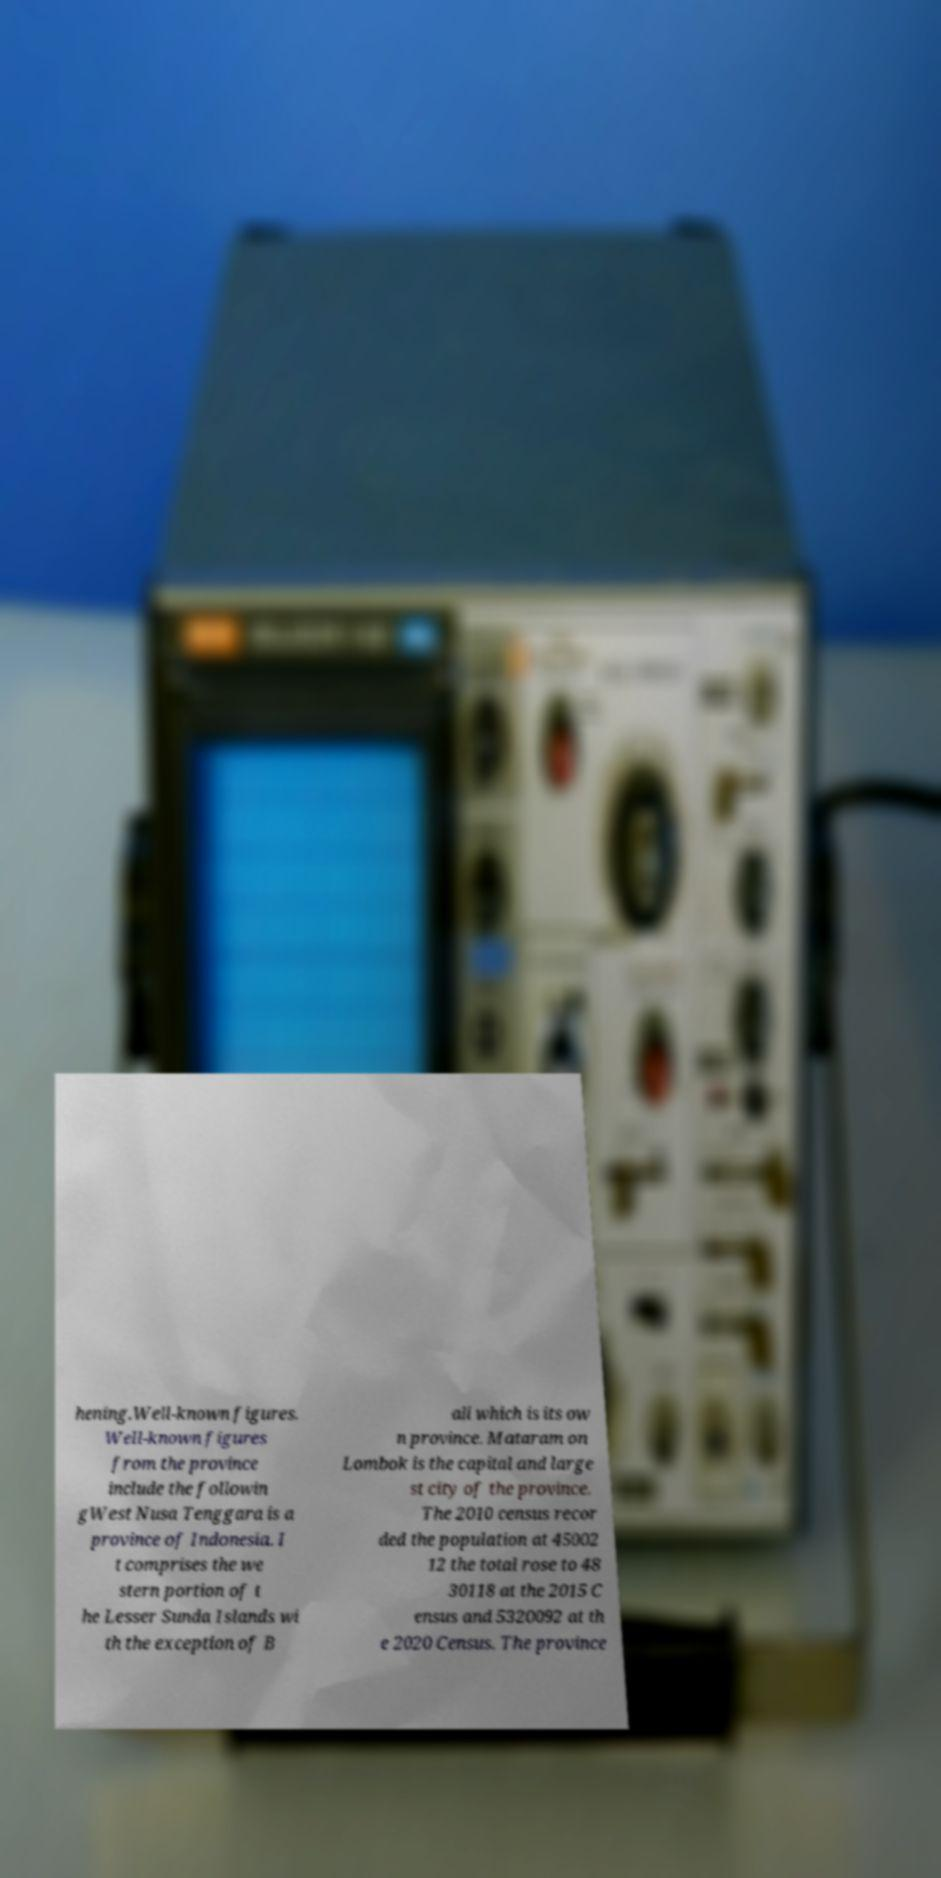Could you assist in decoding the text presented in this image and type it out clearly? hening.Well-known figures. Well-known figures from the province include the followin gWest Nusa Tenggara is a province of Indonesia. I t comprises the we stern portion of t he Lesser Sunda Islands wi th the exception of B ali which is its ow n province. Mataram on Lombok is the capital and large st city of the province. The 2010 census recor ded the population at 45002 12 the total rose to 48 30118 at the 2015 C ensus and 5320092 at th e 2020 Census. The province 